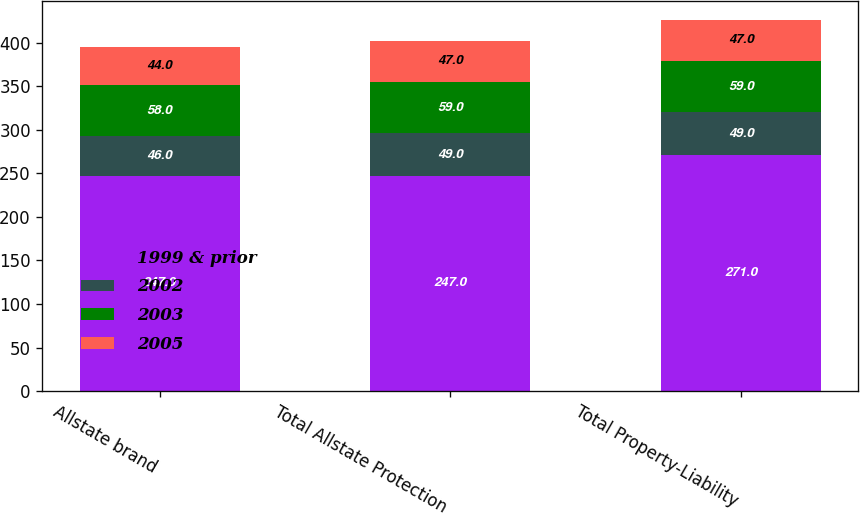<chart> <loc_0><loc_0><loc_500><loc_500><stacked_bar_chart><ecel><fcel>Allstate brand<fcel>Total Allstate Protection<fcel>Total Property-Liability<nl><fcel>1999 & prior<fcel>247<fcel>247<fcel>271<nl><fcel>2002<fcel>46<fcel>49<fcel>49<nl><fcel>2003<fcel>58<fcel>59<fcel>59<nl><fcel>2005<fcel>44<fcel>47<fcel>47<nl></chart> 